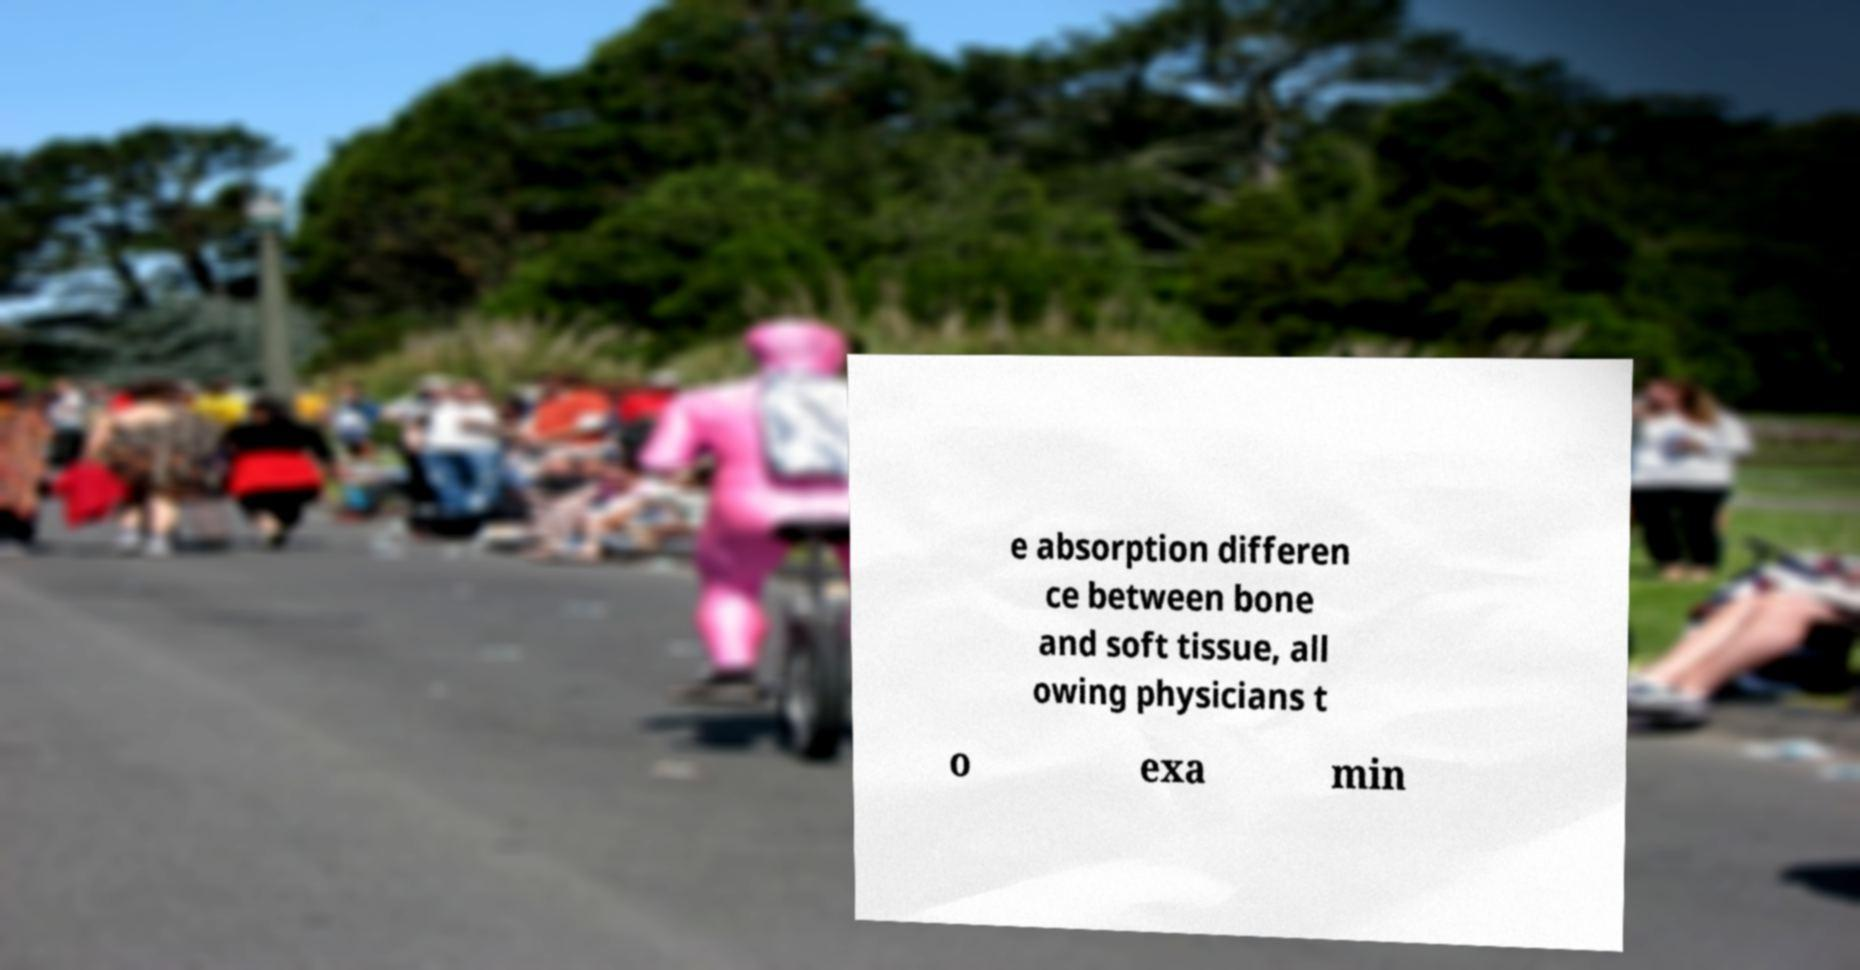Can you accurately transcribe the text from the provided image for me? e absorption differen ce between bone and soft tissue, all owing physicians t o exa min 